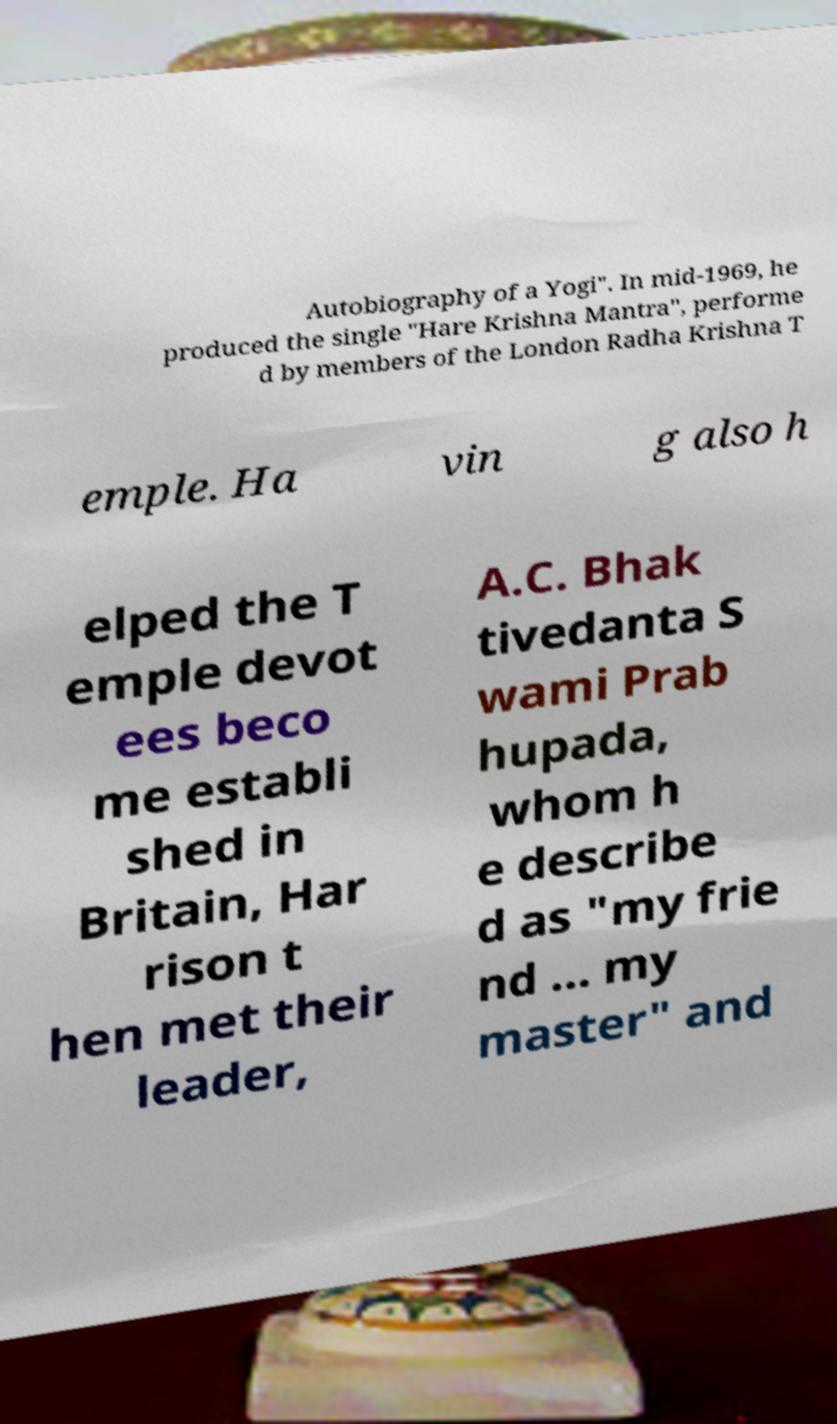There's text embedded in this image that I need extracted. Can you transcribe it verbatim? Autobiography of a Yogi". In mid-1969, he produced the single "Hare Krishna Mantra", performe d by members of the London Radha Krishna T emple. Ha vin g also h elped the T emple devot ees beco me establi shed in Britain, Har rison t hen met their leader, A.C. Bhak tivedanta S wami Prab hupada, whom h e describe d as "my frie nd ... my master" and 